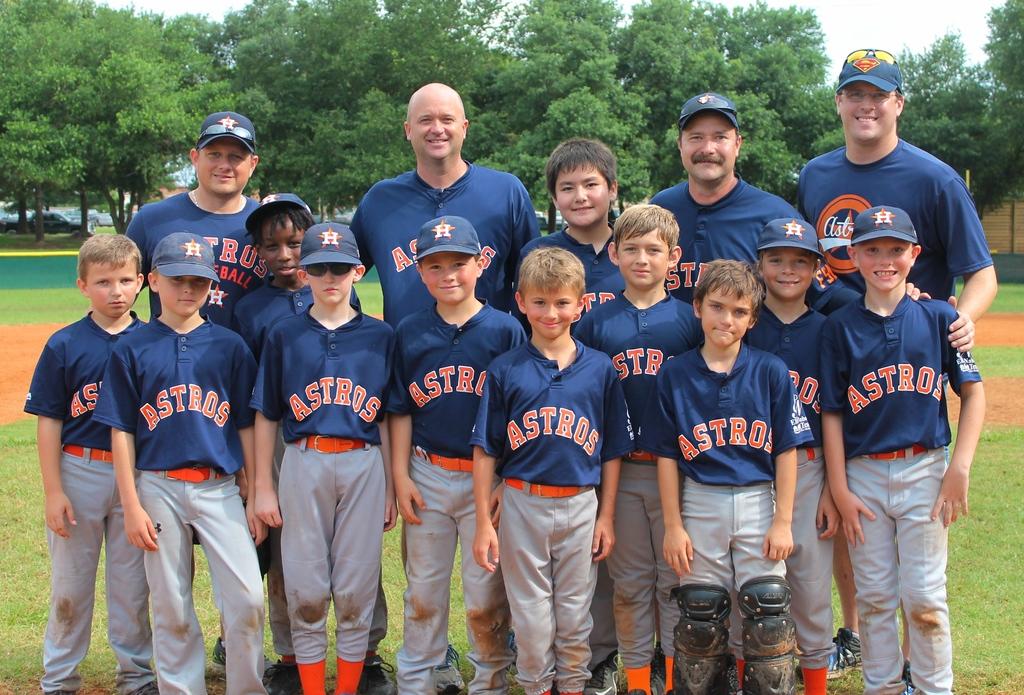What is this baseball team named?
Your answer should be compact. Astros. What letter is on the hat of the man on the far right?
Offer a terse response. S. 